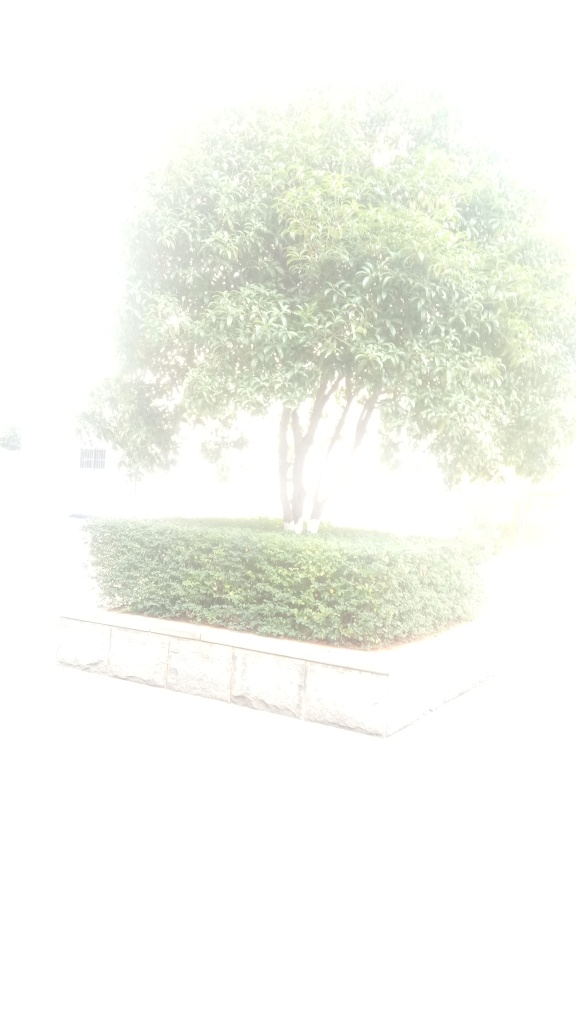What is the quality of this picture? A. Average B. Good C. Very poor The quality of the image is quite poor due to the excessive overexposure, which leaves most details obscured and results in a loss of visual information that would be necessary to properly assess the subject matter of the photo. 